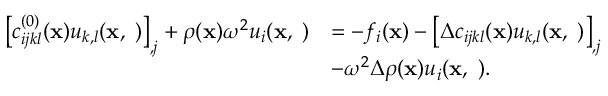Convert formula to latex. <formula><loc_0><loc_0><loc_500><loc_500>\begin{array} { r l } { \left [ c _ { i j k l } ^ { ( 0 ) } ( { x } ) u _ { k , l } ( { x , \omega } ) \right ] _ { , j } + \rho ( { x } ) \omega ^ { 2 } u _ { i } ( { x , \omega } ) } & { = - f _ { i } ( { x } ) - \left [ \Delta c _ { i j k l } ( { x } ) u _ { k , l } ( { x , \omega } ) \right ] _ { , j } } \\ & { - \omega ^ { 2 } \Delta \rho ( { x } ) u _ { i } ( { x , \omega } ) . } \end{array}</formula> 